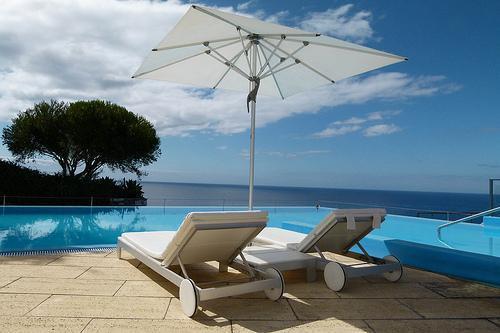How many chairs?
Give a very brief answer. 2. 